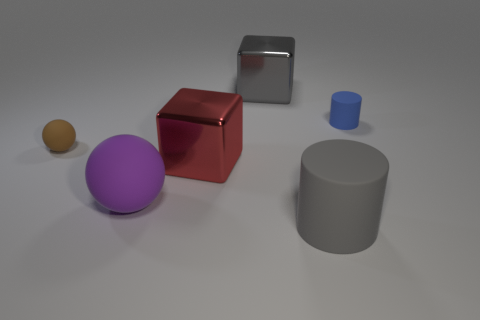What materials appear to be depicted in the objects shown in the image? The materials depicted appear to be a mix of matte and glossy surfaces. The spheres look like they have a matte finish, possibly representing rubber or plastic, while the cubes have a reflective surface, suggesting a metallic material. The cylinder has a slightly less reflective surface, which could either be a matte plastic or painted metal. 